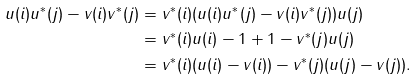<formula> <loc_0><loc_0><loc_500><loc_500>\| u ( i ) u ^ { * } ( j ) - v ( i ) v ^ { * } ( j ) \| & = \| v ^ { * } ( i ) ( u ( i ) u ^ { * } ( j ) - v ( i ) v ^ { * } ( j ) ) u ( j ) \| \\ & = \| v ^ { * } ( i ) u ( i ) - 1 + 1 - v ^ { * } ( j ) u ( j ) \| \\ & = \| v ^ { * } ( i ) ( u ( i ) - v ( i ) ) - v ^ { * } ( j ) ( u ( j ) - v ( j ) ) \| .</formula> 